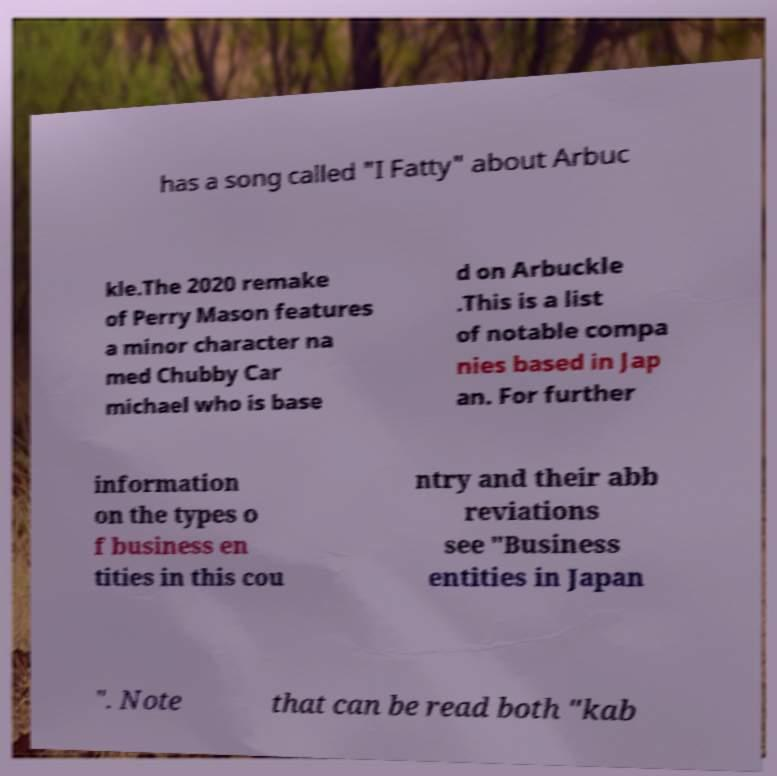There's text embedded in this image that I need extracted. Can you transcribe it verbatim? has a song called "I Fatty" about Arbuc kle.The 2020 remake of Perry Mason features a minor character na med Chubby Car michael who is base d on Arbuckle .This is a list of notable compa nies based in Jap an. For further information on the types o f business en tities in this cou ntry and their abb reviations see "Business entities in Japan ". Note that can be read both "kab 